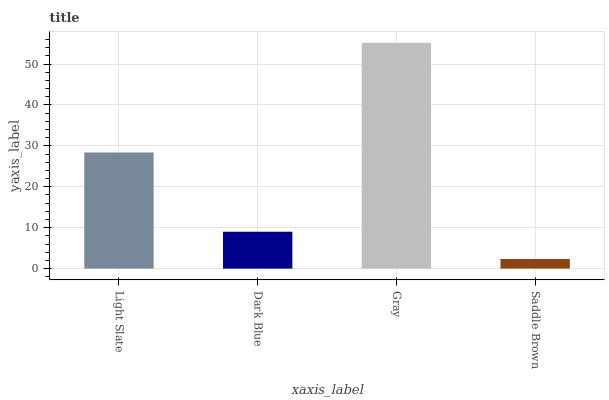Is Saddle Brown the minimum?
Answer yes or no. Yes. Is Gray the maximum?
Answer yes or no. Yes. Is Dark Blue the minimum?
Answer yes or no. No. Is Dark Blue the maximum?
Answer yes or no. No. Is Light Slate greater than Dark Blue?
Answer yes or no. Yes. Is Dark Blue less than Light Slate?
Answer yes or no. Yes. Is Dark Blue greater than Light Slate?
Answer yes or no. No. Is Light Slate less than Dark Blue?
Answer yes or no. No. Is Light Slate the high median?
Answer yes or no. Yes. Is Dark Blue the low median?
Answer yes or no. Yes. Is Saddle Brown the high median?
Answer yes or no. No. Is Light Slate the low median?
Answer yes or no. No. 